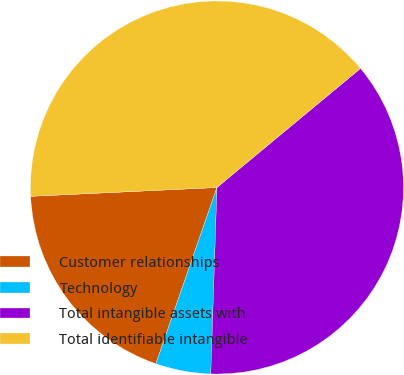Convert chart. <chart><loc_0><loc_0><loc_500><loc_500><pie_chart><fcel>Customer relationships<fcel>Technology<fcel>Total intangible assets with<fcel>Total identifiable intangible<nl><fcel>18.94%<fcel>4.78%<fcel>36.55%<fcel>39.73%<nl></chart> 